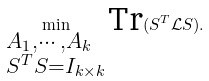<formula> <loc_0><loc_0><loc_500><loc_500>\min _ { \begin{subarray} { c } A _ { 1 } , \cdots , A _ { k } \\ S ^ { T } S = I _ { k \times k } \end{subarray} } \text {Tr} ( S ^ { T } \mathcal { L } S ) .</formula> 